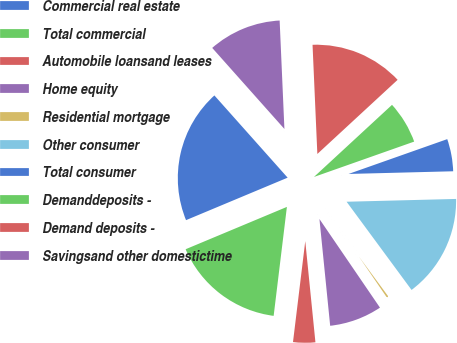Convert chart to OTSL. <chart><loc_0><loc_0><loc_500><loc_500><pie_chart><fcel>Commercial real estate<fcel>Total commercial<fcel>Automobile loansand leases<fcel>Home equity<fcel>Residential mortgage<fcel>Other consumer<fcel>Total consumer<fcel>Demanddeposits -<fcel>Demand deposits -<fcel>Savingsand other domestictime<nl><fcel>19.72%<fcel>16.77%<fcel>3.52%<fcel>7.94%<fcel>0.57%<fcel>15.3%<fcel>4.99%<fcel>6.47%<fcel>13.83%<fcel>10.88%<nl></chart> 